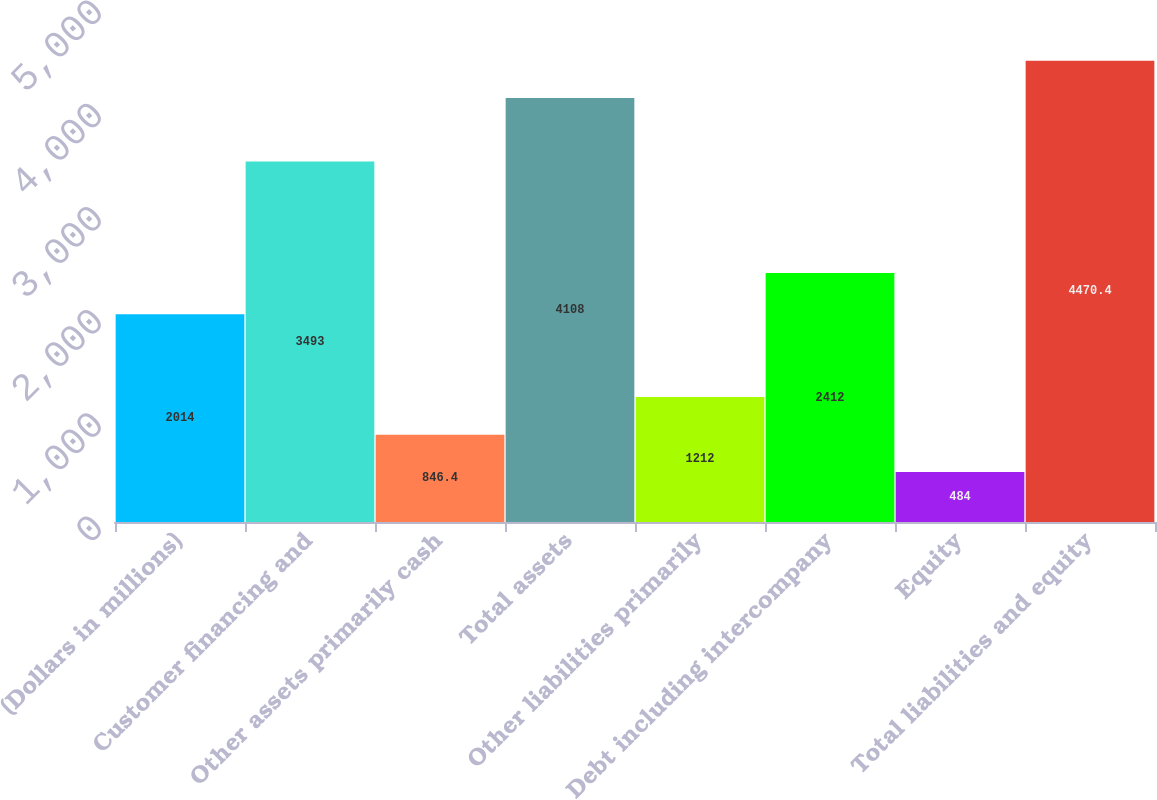<chart> <loc_0><loc_0><loc_500><loc_500><bar_chart><fcel>(Dollars in millions)<fcel>Customer financing and<fcel>Other assets primarily cash<fcel>Total assets<fcel>Other liabilities primarily<fcel>Debt including intercompany<fcel>Equity<fcel>Total liabilities and equity<nl><fcel>2014<fcel>3493<fcel>846.4<fcel>4108<fcel>1212<fcel>2412<fcel>484<fcel>4470.4<nl></chart> 